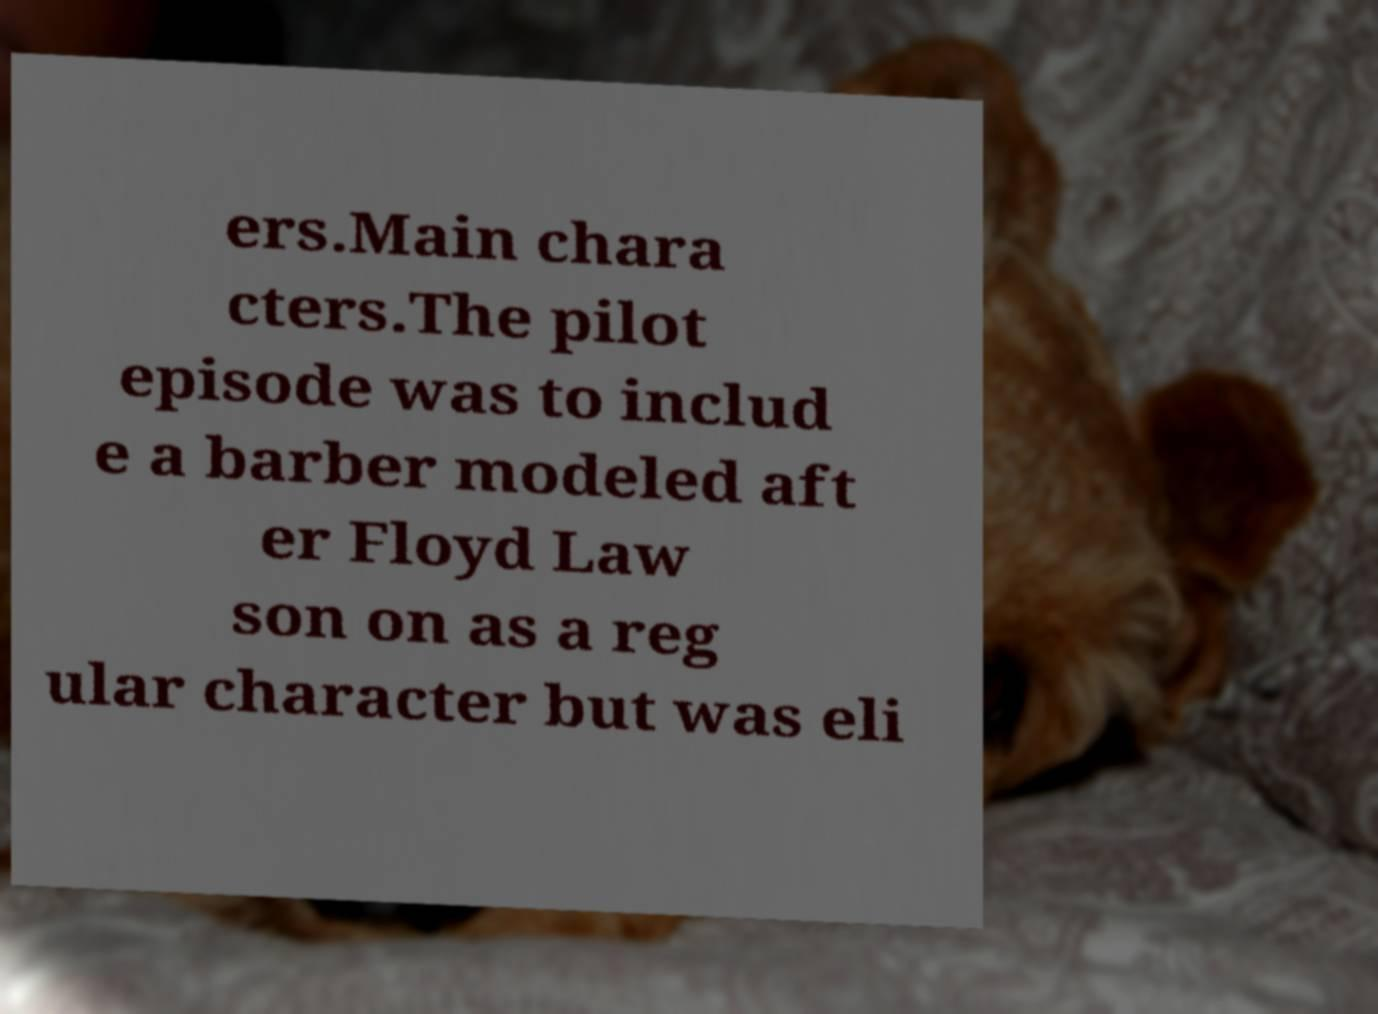Can you read and provide the text displayed in the image?This photo seems to have some interesting text. Can you extract and type it out for me? ers.Main chara cters.The pilot episode was to includ e a barber modeled aft er Floyd Law son on as a reg ular character but was eli 